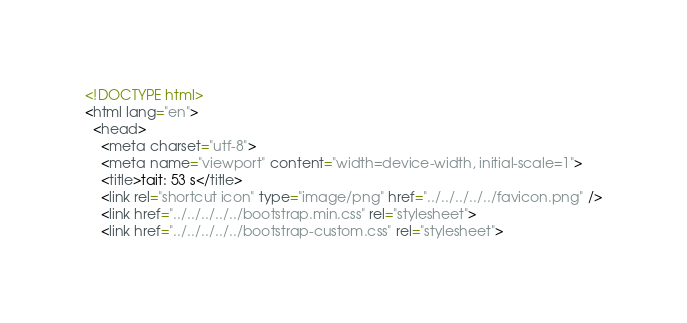Convert code to text. <code><loc_0><loc_0><loc_500><loc_500><_HTML_><!DOCTYPE html>
<html lang="en">
  <head>
    <meta charset="utf-8">
    <meta name="viewport" content="width=device-width, initial-scale=1">
    <title>tait: 53 s</title>
    <link rel="shortcut icon" type="image/png" href="../../../../../favicon.png" />
    <link href="../../../../../bootstrap.min.css" rel="stylesheet">
    <link href="../../../../../bootstrap-custom.css" rel="stylesheet"></code> 